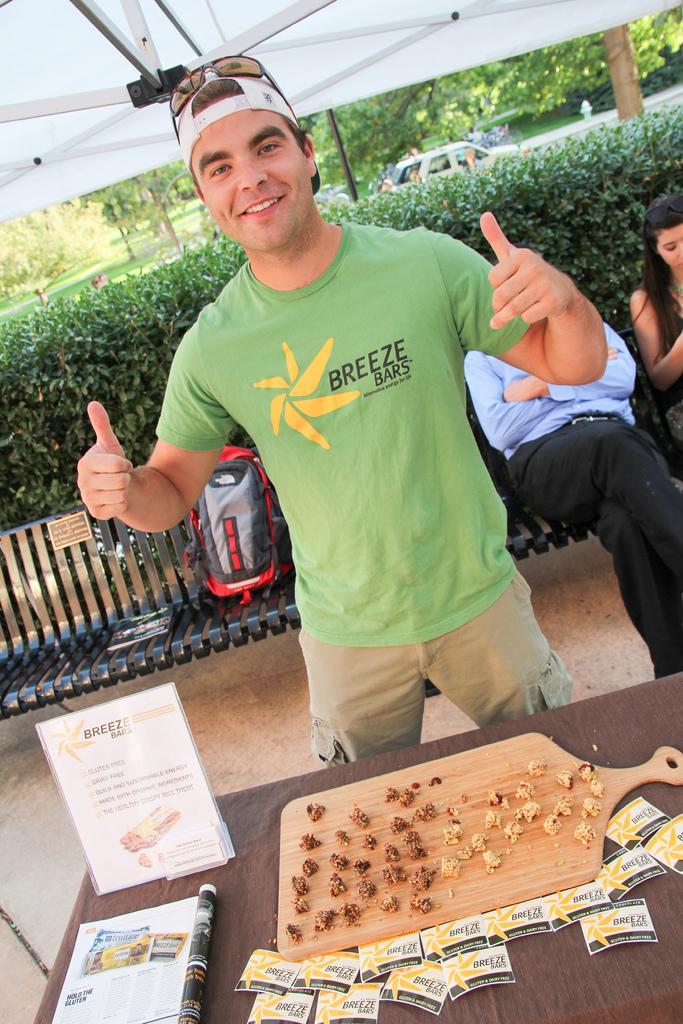Can you describe this image briefly? A person in green shirt is wearing a cap and goggles. In front of him there is table. On the table there is a tray, food items, notices and a book. In the back there is a bench. On the bench there is a bag two persons are sitting. In the background bush, tree and a car is there. 